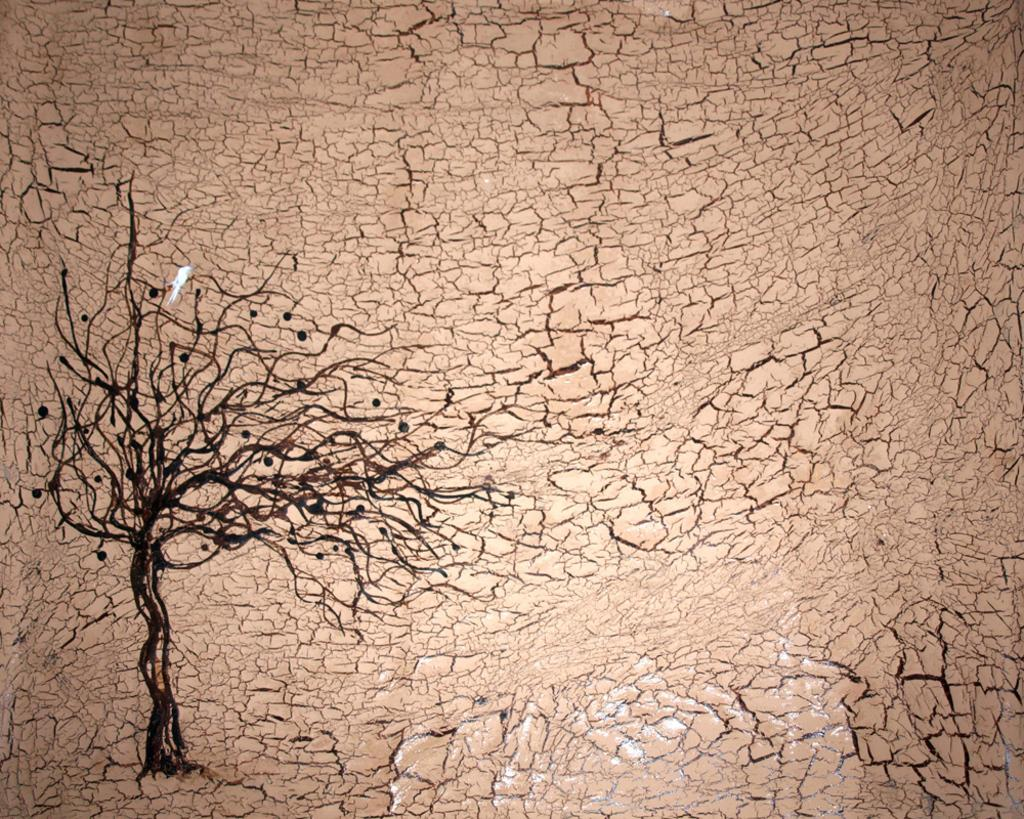What is the main subject of the image? There is a painting in the image. What elements are included in the painting? The painting contains a tree and ground. What type of song can be heard playing in the background of the image? There is no song or audio present in the image, as it is a painting. Is there a scarecrow visible in the painting? There is no scarecrow present in the painting; it only contains a tree and ground. 